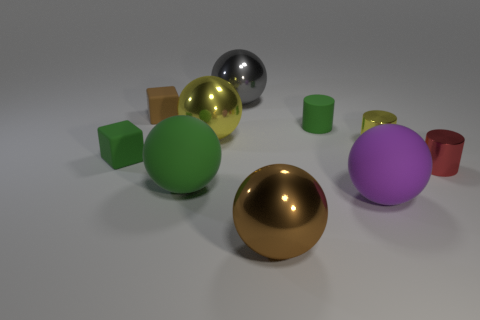Does the yellow thing that is left of the gray metallic ball have the same material as the small green cylinder? The yellow object to the left of the gray metallic sphere appears to be a cube with a glossy surface, which differs from the matte finish of the small green cylinder. Hence, they do not have the same material finish; the cube reflects light and has a sheen suggesting a polished surface, whereas the cylinder's light absorption and diffuse reflection indicate a less reflective, possibly plastic material. 